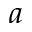<formula> <loc_0><loc_0><loc_500><loc_500>a</formula> 